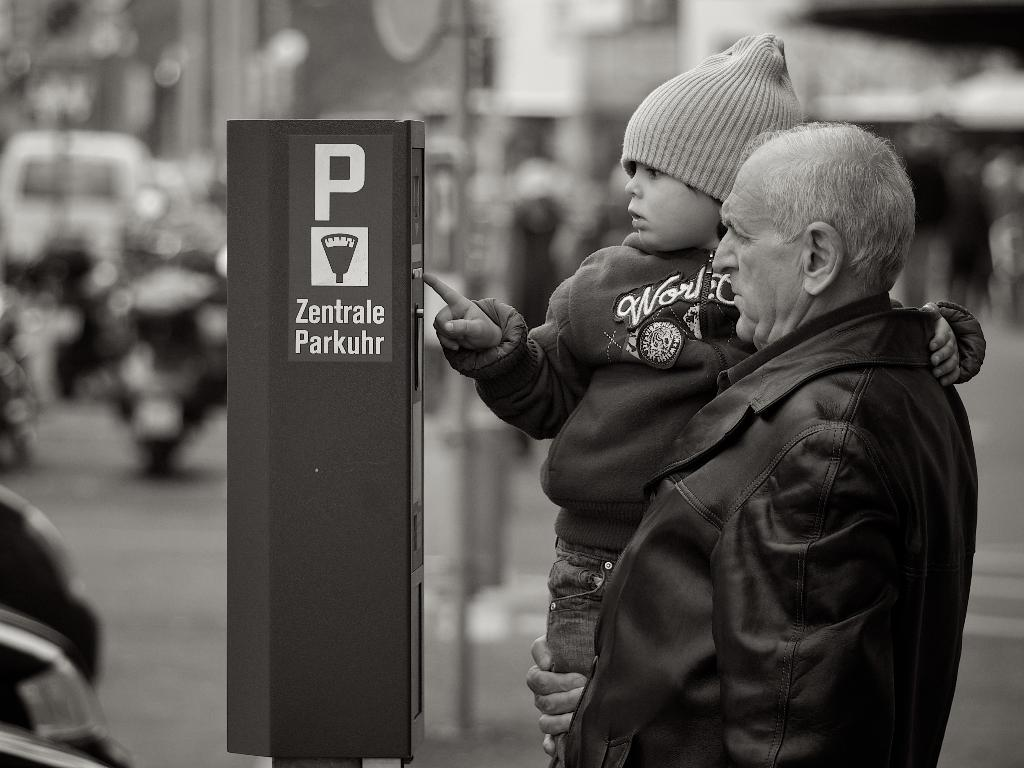<image>
Summarize the visual content of the image. the letter P is on a sign outside 